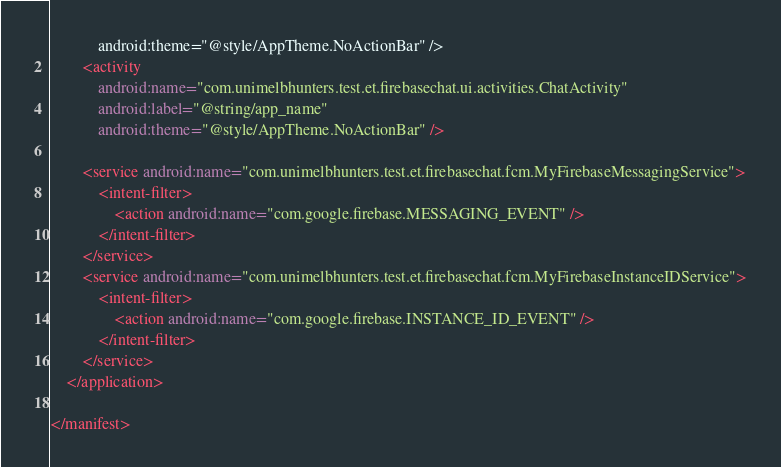<code> <loc_0><loc_0><loc_500><loc_500><_XML_>            android:theme="@style/AppTheme.NoActionBar" />
        <activity
            android:name="com.unimelbhunters.test.et.firebasechat.ui.activities.ChatActivity"
            android:label="@string/app_name"
            android:theme="@style/AppTheme.NoActionBar" />

        <service android:name="com.unimelbhunters.test.et.firebasechat.fcm.MyFirebaseMessagingService">
            <intent-filter>
                <action android:name="com.google.firebase.MESSAGING_EVENT" />
            </intent-filter>
        </service>
        <service android:name="com.unimelbhunters.test.et.firebasechat.fcm.MyFirebaseInstanceIDService">
            <intent-filter>
                <action android:name="com.google.firebase.INSTANCE_ID_EVENT" />
            </intent-filter>
        </service>
    </application>

</manifest></code> 